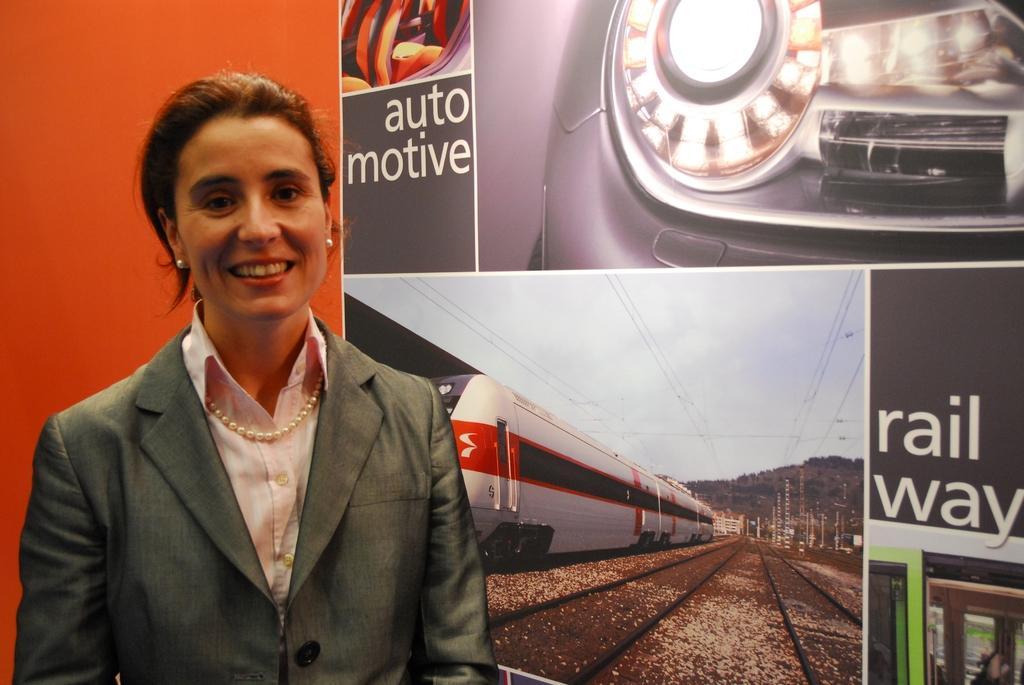Describe this image in one or two sentences. In this image we can see a lady standing and smiling. She is wearing a suit. In the background there is a board. 